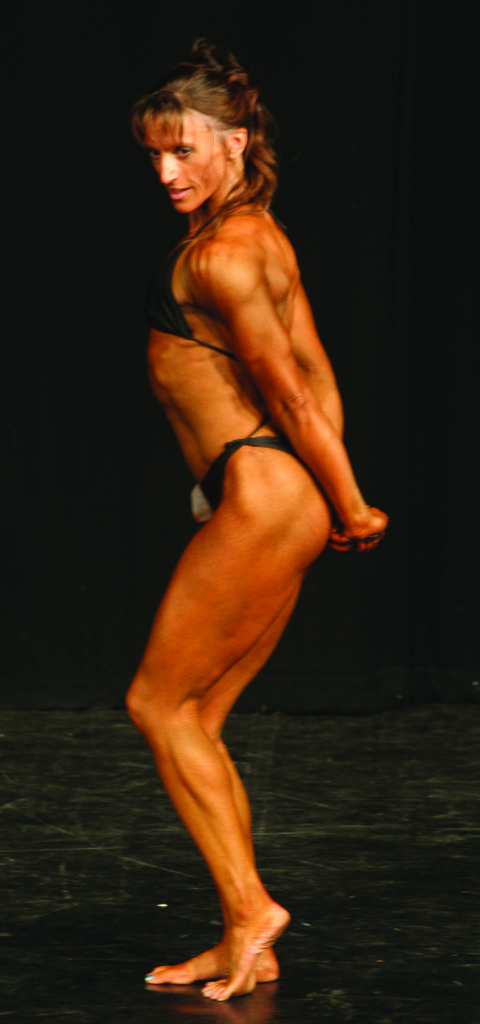Who is the main subject in the image? There is a woman in the image. What is the woman wearing? The woman is wearing a bikini. What color is the background of the image? The background of the image is black. What type of honey is the woman holding in the image? There is no honey present in the image. What joke is the woman telling in the image? There is no joke being told in the image. 